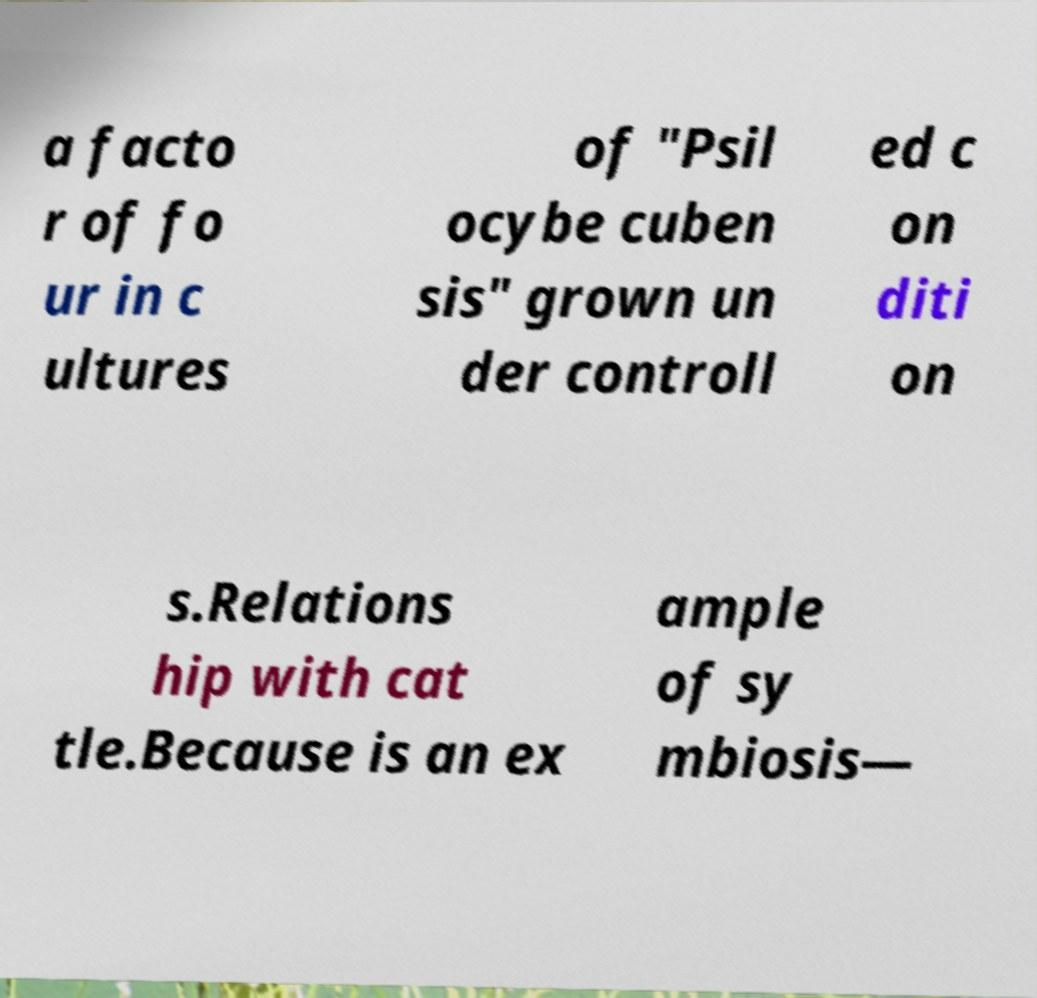I need the written content from this picture converted into text. Can you do that? a facto r of fo ur in c ultures of "Psil ocybe cuben sis" grown un der controll ed c on diti on s.Relations hip with cat tle.Because is an ex ample of sy mbiosis— 